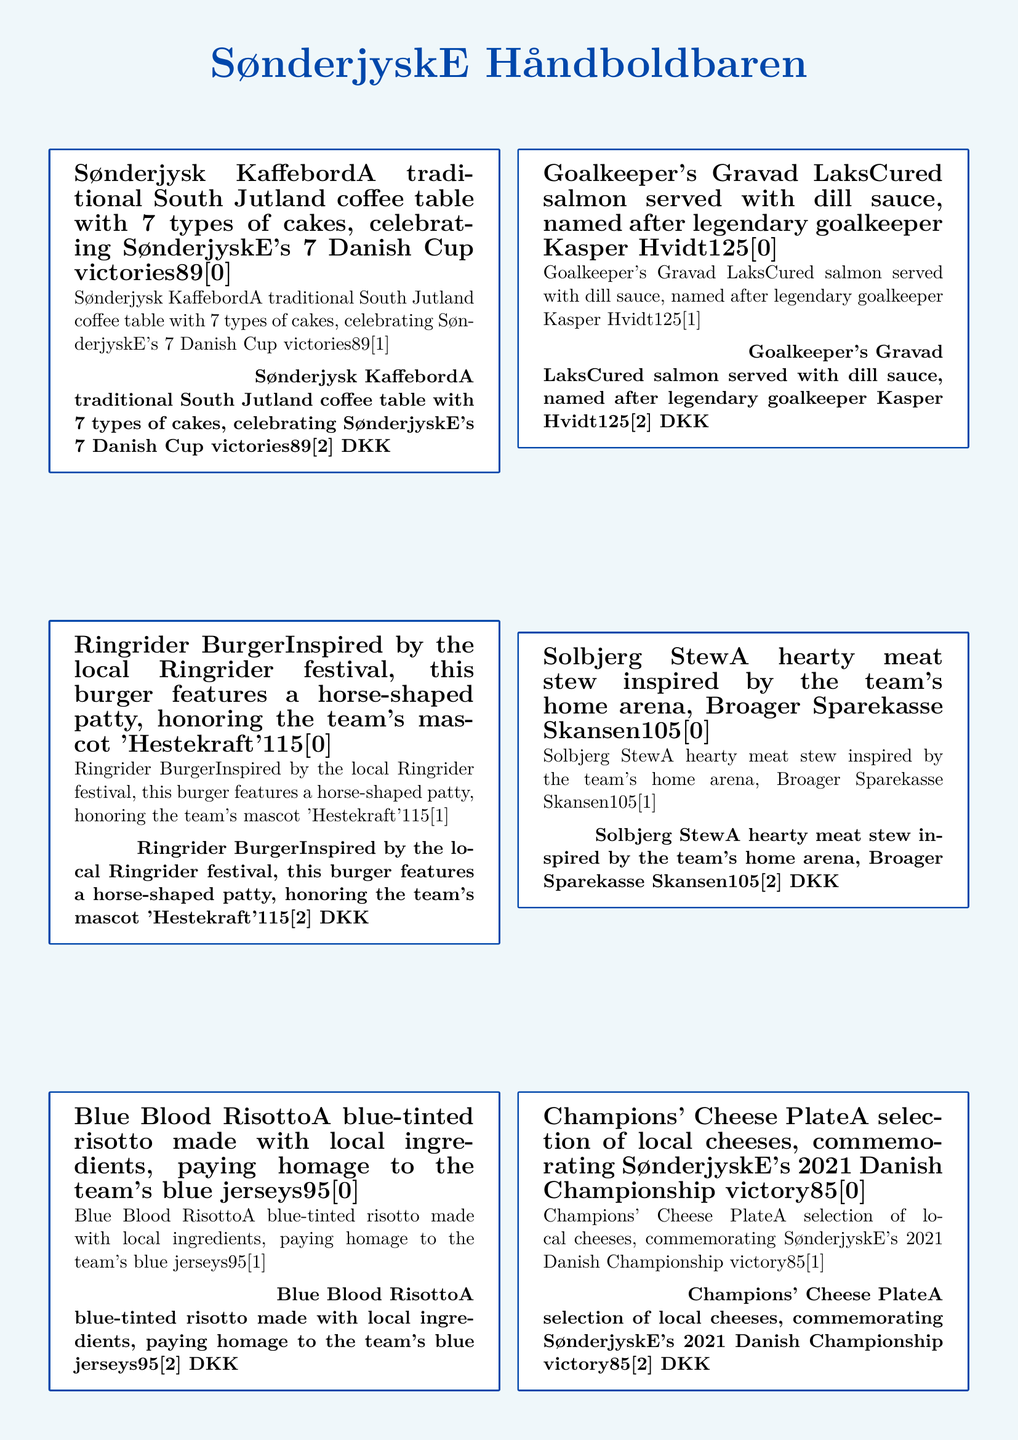What is the first dish listed on the menu? The first dish mentioned in the menu is a traditional South Jutland coffee table, celebrating the team's victories.
Answer: Sønderjysk Kaffebord How many types of cakes are on the Sønderjysk Kaffebord? The dish includes 7 types of cakes, as indicated in the description.
Answer: 7 What is the price of the Goalkeeper's Gravad Laks? The price for the Goalkeeper's Gravad Laks dish is mentioned in the menu.
Answer: 125 DKK Which dish is inspired by a local festival? The burger is inspired by the local Ringrider festival, particularly its unique horse-shaped patty.
Answer: Ringrider Burger What color is the Blue Blood Risotto associated with? The risotto is described as blue-tinted, which connects it to the team's blue jerseys.
Answer: Blue What is served with the Handball Shaped Æbleskiver? The description indicates that the pancake balls are served with jam and powdered sugar.
Answer: Jam and powdered sugar Which dish commemorates SønderjyskE's 2021 Danish Championship victory? The dish specifically celebrating the championship victory is a selection of local cheeses.
Answer: Champions' Cheese Plate What arena is the Solbjerg Stew inspired by? The hearty meat stew is inspired by Broager Sparekasse Skansen, the team’s home arena.
Answer: Broager Sparekasse Skansen How many DKK does the Blue Blood Risotto cost? The menu provides the price for the dish, reflecting its cost.
Answer: 95 DKK 